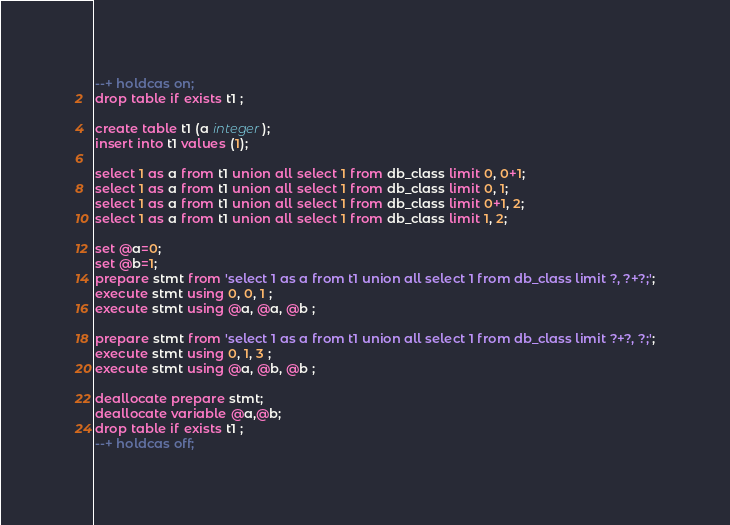<code> <loc_0><loc_0><loc_500><loc_500><_SQL_>--+ holdcas on;
drop table if exists t1 ;

create table t1 (a integer);
insert into t1 values (1);

select 1 as a from t1 union all select 1 from db_class limit 0, 0+1;  
select 1 as a from t1 union all select 1 from db_class limit 0, 1; 
select 1 as a from t1 union all select 1 from db_class limit 0+1, 2;  
select 1 as a from t1 union all select 1 from db_class limit 1, 2; 

set @a=0;
set @b=1;
prepare stmt from 'select 1 as a from t1 union all select 1 from db_class limit ?, ?+?;';
execute stmt using 0, 0, 1 ;
execute stmt using @a, @a, @b ;

prepare stmt from 'select 1 as a from t1 union all select 1 from db_class limit ?+?, ?;';
execute stmt using 0, 1, 3 ;
execute stmt using @a, @b, @b ;

deallocate prepare stmt;
deallocate variable @a,@b;
drop table if exists t1 ;
--+ holdcas off;









</code> 